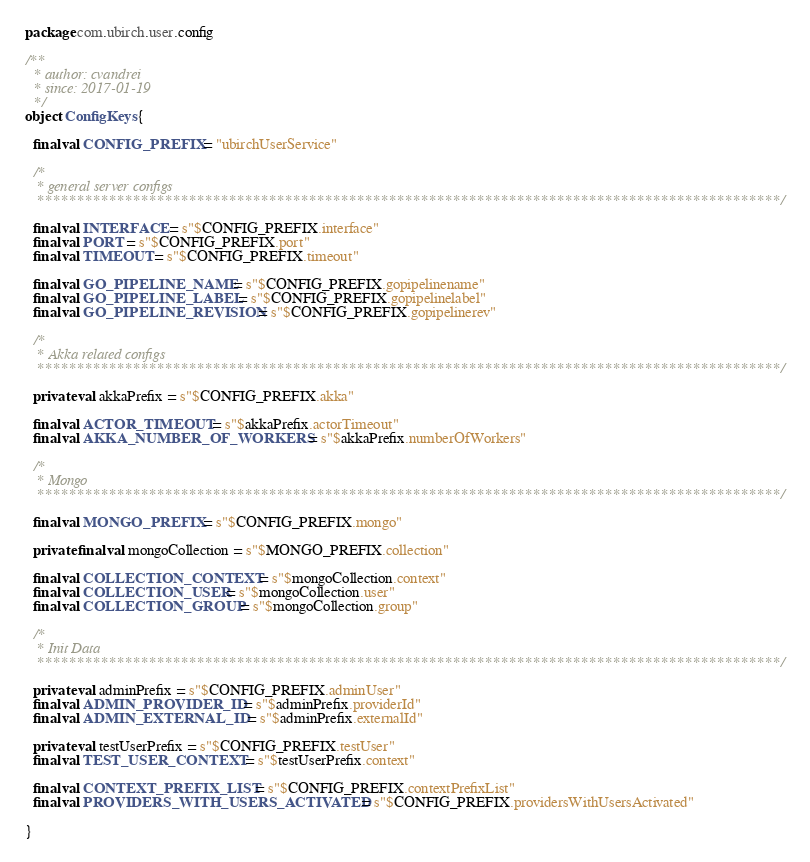<code> <loc_0><loc_0><loc_500><loc_500><_Scala_>package com.ubirch.user.config

/**
  * author: cvandrei
  * since: 2017-01-19
  */
object ConfigKeys {

  final val CONFIG_PREFIX = "ubirchUserService"

  /*
   * general server configs
   *********************************************************************************************/

  final val INTERFACE = s"$CONFIG_PREFIX.interface"
  final val PORT = s"$CONFIG_PREFIX.port"
  final val TIMEOUT = s"$CONFIG_PREFIX.timeout"

  final val GO_PIPELINE_NAME = s"$CONFIG_PREFIX.gopipelinename"
  final val GO_PIPELINE_LABEL = s"$CONFIG_PREFIX.gopipelinelabel"
  final val GO_PIPELINE_REVISION = s"$CONFIG_PREFIX.gopipelinerev"

  /*
   * Akka related configs
   *********************************************************************************************/

  private val akkaPrefix = s"$CONFIG_PREFIX.akka"

  final val ACTOR_TIMEOUT = s"$akkaPrefix.actorTimeout"
  final val AKKA_NUMBER_OF_WORKERS = s"$akkaPrefix.numberOfWorkers"

  /*
   * Mongo
   *********************************************************************************************/

  final val MONGO_PREFIX = s"$CONFIG_PREFIX.mongo"

  private final val mongoCollection = s"$MONGO_PREFIX.collection"

  final val COLLECTION_CONTEXT = s"$mongoCollection.context"
  final val COLLECTION_USER = s"$mongoCollection.user"
  final val COLLECTION_GROUP = s"$mongoCollection.group"

  /*
   * Init Data
   *********************************************************************************************/

  private val adminPrefix = s"$CONFIG_PREFIX.adminUser"
  final val ADMIN_PROVIDER_ID = s"$adminPrefix.providerId"
  final val ADMIN_EXTERNAL_ID = s"$adminPrefix.externalId"

  private val testUserPrefix = s"$CONFIG_PREFIX.testUser"
  final val TEST_USER_CONTEXT = s"$testUserPrefix.context"

  final val CONTEXT_PREFIX_LIST = s"$CONFIG_PREFIX.contextPrefixList"
  final val PROVIDERS_WITH_USERS_ACTIVATED = s"$CONFIG_PREFIX.providersWithUsersActivated"

}
</code> 